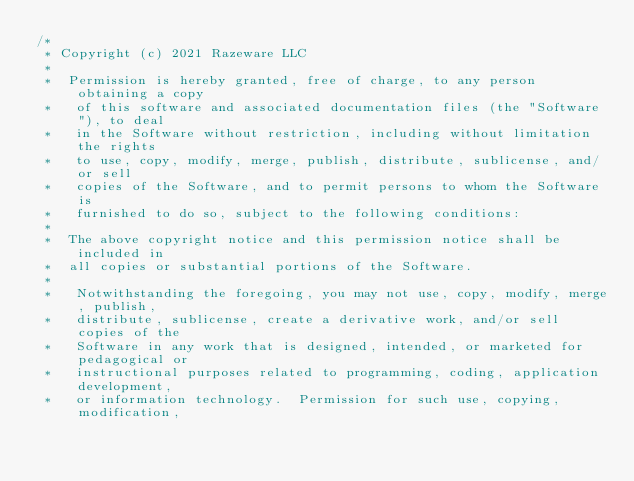<code> <loc_0><loc_0><loc_500><loc_500><_Kotlin_>/*
 * Copyright (c) 2021 Razeware LLC
 *   
 *  Permission is hereby granted, free of charge, to any person obtaining a copy
 *   of this software and associated documentation files (the "Software"), to deal
 *   in the Software without restriction, including without limitation the rights
 *   to use, copy, modify, merge, publish, distribute, sublicense, and/or sell
 *   copies of the Software, and to permit persons to whom the Software is
 *   furnished to do so, subject to the following conditions:
 *   
 *  The above copyright notice and this permission notice shall be included in
 *  all copies or substantial portions of the Software.
 *   
 *   Notwithstanding the foregoing, you may not use, copy, modify, merge, publish,
 *   distribute, sublicense, create a derivative work, and/or sell copies of the
 *   Software in any work that is designed, intended, or marketed for pedagogical or
 *   instructional purposes related to programming, coding, application development,
 *   or information technology.  Permission for such use, copying, modification,</code> 